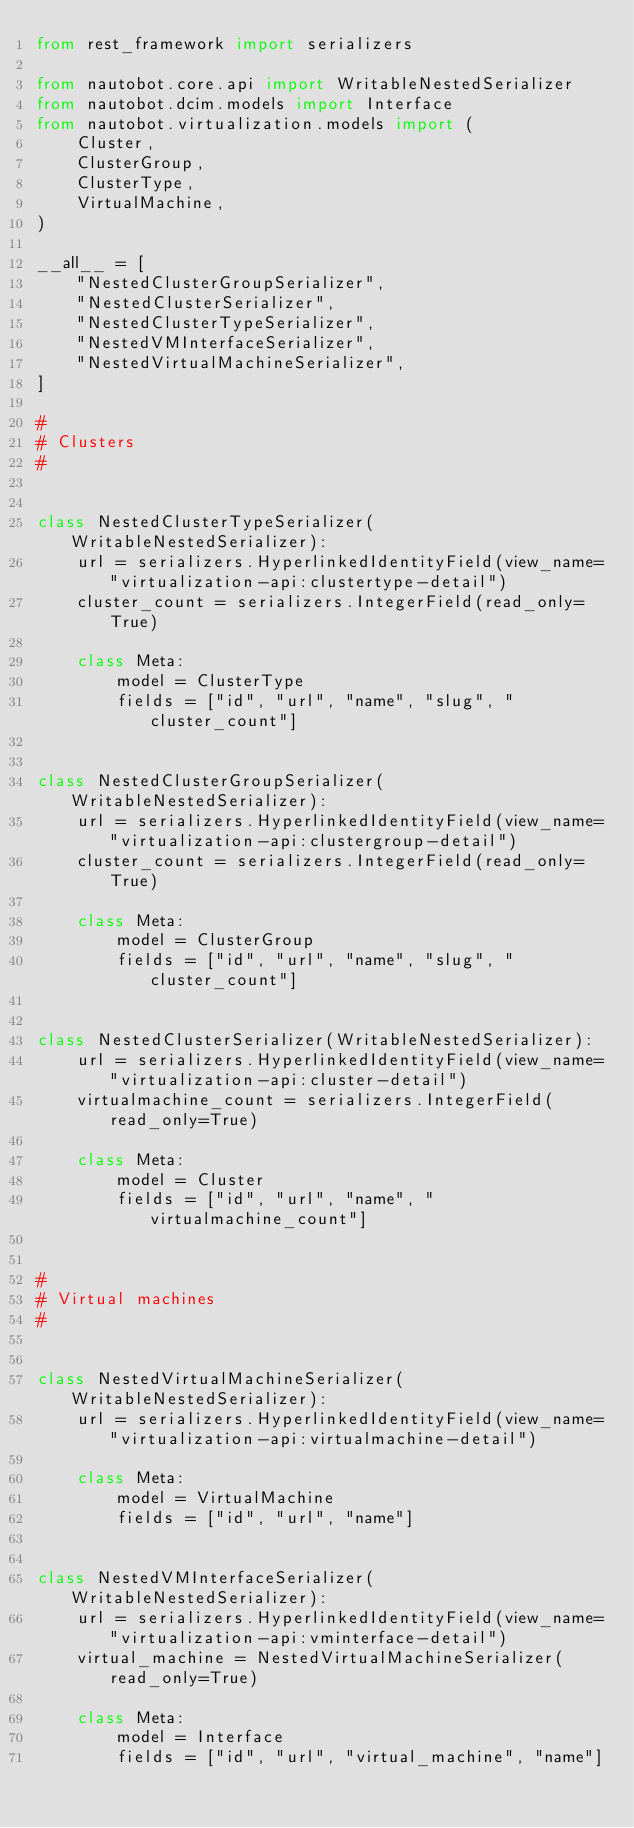Convert code to text. <code><loc_0><loc_0><loc_500><loc_500><_Python_>from rest_framework import serializers

from nautobot.core.api import WritableNestedSerializer
from nautobot.dcim.models import Interface
from nautobot.virtualization.models import (
    Cluster,
    ClusterGroup,
    ClusterType,
    VirtualMachine,
)

__all__ = [
    "NestedClusterGroupSerializer",
    "NestedClusterSerializer",
    "NestedClusterTypeSerializer",
    "NestedVMInterfaceSerializer",
    "NestedVirtualMachineSerializer",
]

#
# Clusters
#


class NestedClusterTypeSerializer(WritableNestedSerializer):
    url = serializers.HyperlinkedIdentityField(view_name="virtualization-api:clustertype-detail")
    cluster_count = serializers.IntegerField(read_only=True)

    class Meta:
        model = ClusterType
        fields = ["id", "url", "name", "slug", "cluster_count"]


class NestedClusterGroupSerializer(WritableNestedSerializer):
    url = serializers.HyperlinkedIdentityField(view_name="virtualization-api:clustergroup-detail")
    cluster_count = serializers.IntegerField(read_only=True)

    class Meta:
        model = ClusterGroup
        fields = ["id", "url", "name", "slug", "cluster_count"]


class NestedClusterSerializer(WritableNestedSerializer):
    url = serializers.HyperlinkedIdentityField(view_name="virtualization-api:cluster-detail")
    virtualmachine_count = serializers.IntegerField(read_only=True)

    class Meta:
        model = Cluster
        fields = ["id", "url", "name", "virtualmachine_count"]


#
# Virtual machines
#


class NestedVirtualMachineSerializer(WritableNestedSerializer):
    url = serializers.HyperlinkedIdentityField(view_name="virtualization-api:virtualmachine-detail")

    class Meta:
        model = VirtualMachine
        fields = ["id", "url", "name"]


class NestedVMInterfaceSerializer(WritableNestedSerializer):
    url = serializers.HyperlinkedIdentityField(view_name="virtualization-api:vminterface-detail")
    virtual_machine = NestedVirtualMachineSerializer(read_only=True)

    class Meta:
        model = Interface
        fields = ["id", "url", "virtual_machine", "name"]
</code> 